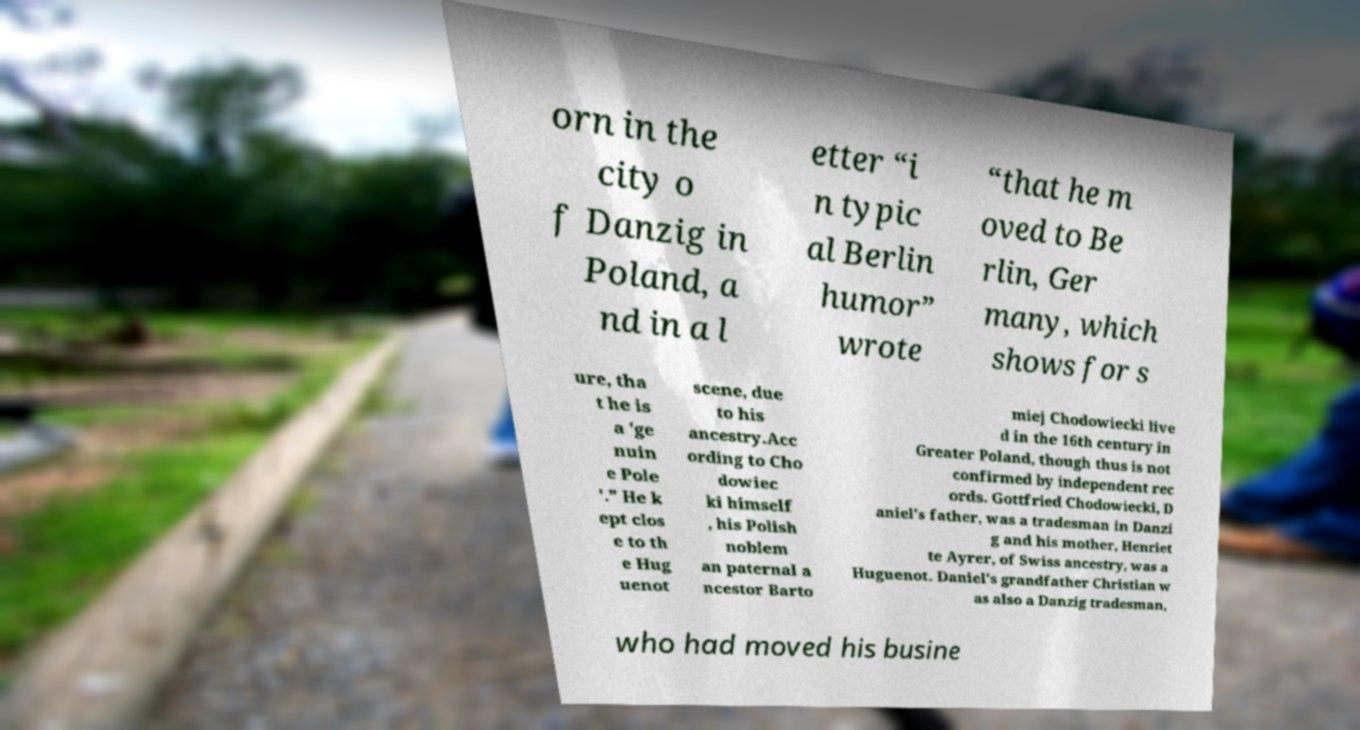What messages or text are displayed in this image? I need them in a readable, typed format. orn in the city o f Danzig in Poland, a nd in a l etter “i n typic al Berlin humor” wrote “that he m oved to Be rlin, Ger many, which shows for s ure, tha t he is a 'ge nuin e Pole '.” He k ept clos e to th e Hug uenot scene, due to his ancestry.Acc ording to Cho dowiec ki himself , his Polish noblem an paternal a ncestor Barto miej Chodowiecki live d in the 16th century in Greater Poland, though thus is not confirmed by independent rec ords. Gottfried Chodowiecki, D aniel's father, was a tradesman in Danzi g and his mother, Henriet te Ayrer, of Swiss ancestry, was a Huguenot. Daniel's grandfather Christian w as also a Danzig tradesman, who had moved his busine 